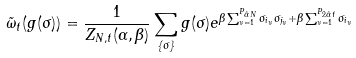<formula> <loc_0><loc_0><loc_500><loc_500>\tilde { \omega } _ { t } ( g ( \sigma ) ) = \frac { 1 } { Z _ { N , t } ( \alpha , \beta ) } \sum _ { \{ \sigma \} } g ( \sigma ) e ^ { \beta \sum _ { \nu = 1 } ^ { P _ { \tilde { \alpha } N } } \sigma _ { i _ { \nu } } \sigma _ { j _ { \nu } } + \beta \sum _ { \nu = 1 } ^ { P _ { 2 \tilde { \alpha } t } } \sigma _ { i _ { \nu } } }</formula> 